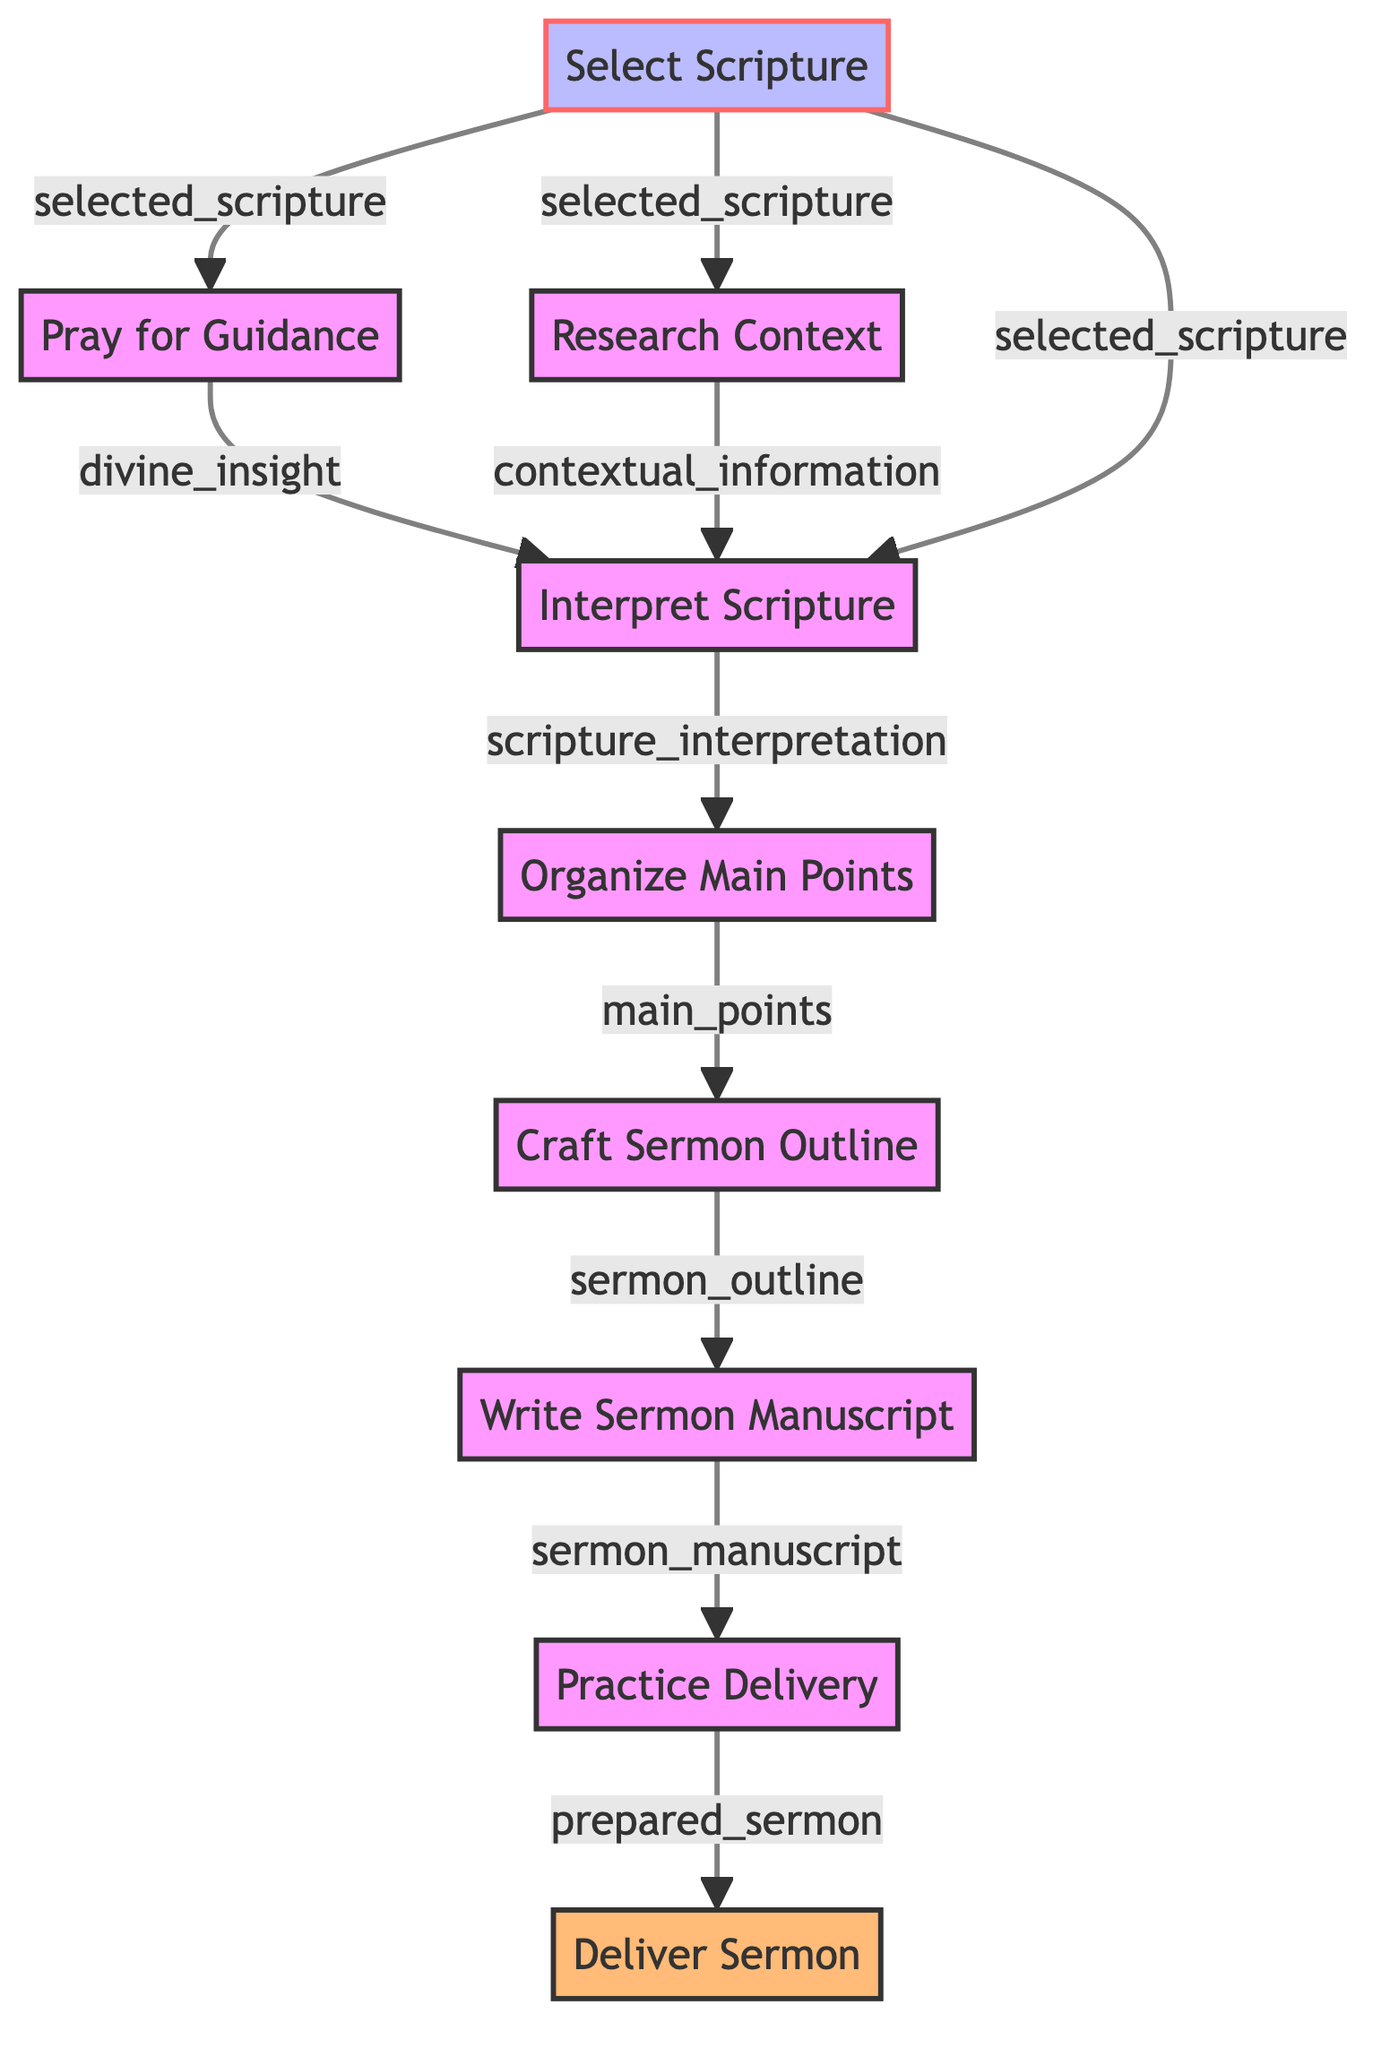What is the first step in preparing a sermon? The first step is to select the scripture. This is indicated by the first node in the flowchart, which clearly shows that "Select Scripture" is the starting point of the process.
Answer: Select Scripture How many steps are there in the flowchart? By counting the nodes in the diagram, we can see that there are nine distinct steps involved in preparing a sermon.
Answer: 9 Which step directly follows "Pray for Guidance"? The step that follows "Pray for Guidance" is "Interpret Scripture." This can be deduced by observing the directional flow from node 2 to node 4 in the diagram.
Answer: Interpret Scripture What is the output of the "Craft Sermon Outline" step? The output of the "Craft Sermon Outline" step is "sermon_outline." This is indicated in the diagram as an output that results from the input at that node.
Answer: sermon_outline How many inputs does the "Interpret Scripture" step require? The "Interpret Scripture" step requires three inputs: "selected_scripture," "contextual_information," and "divine_insight." This is evident from the flowing arrows leading into that node in the diagram.
Answer: 3 What is the final output of the entire process? The final output of the entire process is "delivered_sermon," which is the last node in the flowchart. This can be determined as it represents the conclusion of the sermon preparation steps.
Answer: delivered_sermon Which step starts with prayer? The step that involves prayer is "Pray for Guidance." This is clearly marked as the second step in the flowchart, following the selection of scripture.
Answer: Pray for Guidance What precedes "Practice Delivery"? The step that precedes "Practice Delivery" is "Write Sermon Manuscript." This can be seen in the flow of the diagram, leading from node 7 to node 8.
Answer: Write Sermon Manuscript Which step involves analyzing the meaning of the scripture? The step that involves analyzing the meaning of the scripture is "Interpret Scripture." This is explicitly stated as the fourth step in the process according to the flowchart.
Answer: Interpret Scripture 